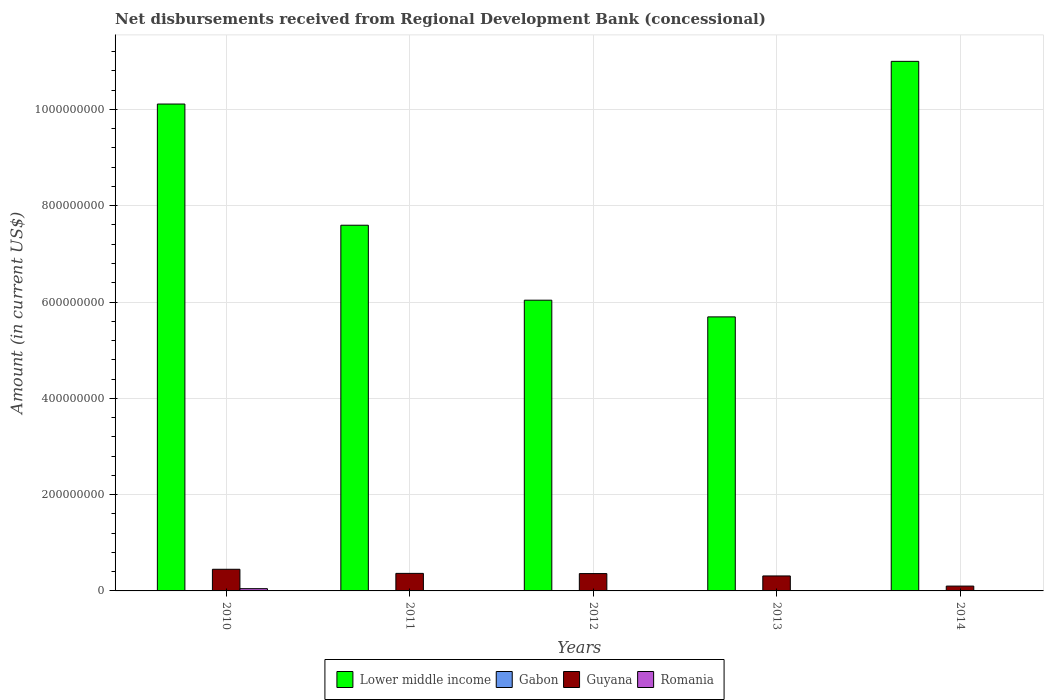What is the label of the 4th group of bars from the left?
Offer a terse response. 2013. What is the amount of disbursements received from Regional Development Bank in Gabon in 2012?
Your response must be concise. 0. Across all years, what is the maximum amount of disbursements received from Regional Development Bank in Romania?
Ensure brevity in your answer.  4.69e+06. Across all years, what is the minimum amount of disbursements received from Regional Development Bank in Lower middle income?
Offer a terse response. 5.69e+08. In which year was the amount of disbursements received from Regional Development Bank in Lower middle income maximum?
Provide a succinct answer. 2014. What is the total amount of disbursements received from Regional Development Bank in Romania in the graph?
Make the answer very short. 4.69e+06. What is the difference between the amount of disbursements received from Regional Development Bank in Guyana in 2011 and that in 2014?
Provide a succinct answer. 2.64e+07. What is the difference between the amount of disbursements received from Regional Development Bank in Gabon in 2011 and the amount of disbursements received from Regional Development Bank in Lower middle income in 2014?
Provide a short and direct response. -1.10e+09. What is the average amount of disbursements received from Regional Development Bank in Guyana per year?
Keep it short and to the point. 3.17e+07. In the year 2011, what is the difference between the amount of disbursements received from Regional Development Bank in Guyana and amount of disbursements received from Regional Development Bank in Lower middle income?
Ensure brevity in your answer.  -7.23e+08. In how many years, is the amount of disbursements received from Regional Development Bank in Romania greater than 680000000 US$?
Your response must be concise. 0. What is the ratio of the amount of disbursements received from Regional Development Bank in Guyana in 2013 to that in 2014?
Your answer should be very brief. 3.1. Is the amount of disbursements received from Regional Development Bank in Guyana in 2010 less than that in 2012?
Your answer should be compact. No. What is the difference between the highest and the second highest amount of disbursements received from Regional Development Bank in Lower middle income?
Keep it short and to the point. 8.86e+07. What is the difference between the highest and the lowest amount of disbursements received from Regional Development Bank in Lower middle income?
Your answer should be compact. 5.31e+08. In how many years, is the amount of disbursements received from Regional Development Bank in Guyana greater than the average amount of disbursements received from Regional Development Bank in Guyana taken over all years?
Make the answer very short. 3. Is it the case that in every year, the sum of the amount of disbursements received from Regional Development Bank in Lower middle income and amount of disbursements received from Regional Development Bank in Gabon is greater than the sum of amount of disbursements received from Regional Development Bank in Romania and amount of disbursements received from Regional Development Bank in Guyana?
Ensure brevity in your answer.  No. How many bars are there?
Your response must be concise. 11. Are all the bars in the graph horizontal?
Your response must be concise. No. What is the difference between two consecutive major ticks on the Y-axis?
Provide a short and direct response. 2.00e+08. Where does the legend appear in the graph?
Give a very brief answer. Bottom center. How are the legend labels stacked?
Offer a terse response. Horizontal. What is the title of the graph?
Provide a succinct answer. Net disbursements received from Regional Development Bank (concessional). Does "Korea (Republic)" appear as one of the legend labels in the graph?
Offer a very short reply. No. What is the label or title of the Y-axis?
Provide a short and direct response. Amount (in current US$). What is the Amount (in current US$) of Lower middle income in 2010?
Give a very brief answer. 1.01e+09. What is the Amount (in current US$) in Guyana in 2010?
Make the answer very short. 4.50e+07. What is the Amount (in current US$) of Romania in 2010?
Make the answer very short. 4.69e+06. What is the Amount (in current US$) in Lower middle income in 2011?
Provide a short and direct response. 7.59e+08. What is the Amount (in current US$) of Guyana in 2011?
Ensure brevity in your answer.  3.64e+07. What is the Amount (in current US$) of Romania in 2011?
Your response must be concise. 0. What is the Amount (in current US$) in Lower middle income in 2012?
Keep it short and to the point. 6.04e+08. What is the Amount (in current US$) of Guyana in 2012?
Provide a short and direct response. 3.60e+07. What is the Amount (in current US$) of Romania in 2012?
Provide a succinct answer. 0. What is the Amount (in current US$) of Lower middle income in 2013?
Your response must be concise. 5.69e+08. What is the Amount (in current US$) of Guyana in 2013?
Give a very brief answer. 3.11e+07. What is the Amount (in current US$) in Lower middle income in 2014?
Your answer should be very brief. 1.10e+09. What is the Amount (in current US$) in Gabon in 2014?
Ensure brevity in your answer.  0. What is the Amount (in current US$) in Guyana in 2014?
Keep it short and to the point. 1.00e+07. Across all years, what is the maximum Amount (in current US$) in Lower middle income?
Provide a short and direct response. 1.10e+09. Across all years, what is the maximum Amount (in current US$) of Guyana?
Offer a terse response. 4.50e+07. Across all years, what is the maximum Amount (in current US$) of Romania?
Ensure brevity in your answer.  4.69e+06. Across all years, what is the minimum Amount (in current US$) of Lower middle income?
Offer a terse response. 5.69e+08. Across all years, what is the minimum Amount (in current US$) in Guyana?
Ensure brevity in your answer.  1.00e+07. Across all years, what is the minimum Amount (in current US$) of Romania?
Provide a short and direct response. 0. What is the total Amount (in current US$) in Lower middle income in the graph?
Your response must be concise. 4.04e+09. What is the total Amount (in current US$) in Guyana in the graph?
Your answer should be compact. 1.59e+08. What is the total Amount (in current US$) in Romania in the graph?
Offer a terse response. 4.69e+06. What is the difference between the Amount (in current US$) in Lower middle income in 2010 and that in 2011?
Provide a succinct answer. 2.52e+08. What is the difference between the Amount (in current US$) of Guyana in 2010 and that in 2011?
Provide a short and direct response. 8.54e+06. What is the difference between the Amount (in current US$) in Lower middle income in 2010 and that in 2012?
Give a very brief answer. 4.07e+08. What is the difference between the Amount (in current US$) in Guyana in 2010 and that in 2012?
Offer a terse response. 8.96e+06. What is the difference between the Amount (in current US$) in Lower middle income in 2010 and that in 2013?
Provide a succinct answer. 4.42e+08. What is the difference between the Amount (in current US$) of Guyana in 2010 and that in 2013?
Provide a short and direct response. 1.39e+07. What is the difference between the Amount (in current US$) of Lower middle income in 2010 and that in 2014?
Ensure brevity in your answer.  -8.86e+07. What is the difference between the Amount (in current US$) of Guyana in 2010 and that in 2014?
Provide a succinct answer. 3.49e+07. What is the difference between the Amount (in current US$) of Lower middle income in 2011 and that in 2012?
Your answer should be very brief. 1.56e+08. What is the difference between the Amount (in current US$) of Guyana in 2011 and that in 2012?
Your answer should be very brief. 4.26e+05. What is the difference between the Amount (in current US$) in Lower middle income in 2011 and that in 2013?
Offer a terse response. 1.90e+08. What is the difference between the Amount (in current US$) of Guyana in 2011 and that in 2013?
Provide a short and direct response. 5.32e+06. What is the difference between the Amount (in current US$) of Lower middle income in 2011 and that in 2014?
Your answer should be very brief. -3.40e+08. What is the difference between the Amount (in current US$) of Guyana in 2011 and that in 2014?
Provide a succinct answer. 2.64e+07. What is the difference between the Amount (in current US$) of Lower middle income in 2012 and that in 2013?
Give a very brief answer. 3.47e+07. What is the difference between the Amount (in current US$) of Guyana in 2012 and that in 2013?
Offer a very short reply. 4.90e+06. What is the difference between the Amount (in current US$) of Lower middle income in 2012 and that in 2014?
Your response must be concise. -4.96e+08. What is the difference between the Amount (in current US$) in Guyana in 2012 and that in 2014?
Keep it short and to the point. 2.60e+07. What is the difference between the Amount (in current US$) of Lower middle income in 2013 and that in 2014?
Offer a very short reply. -5.31e+08. What is the difference between the Amount (in current US$) of Guyana in 2013 and that in 2014?
Your answer should be very brief. 2.11e+07. What is the difference between the Amount (in current US$) of Lower middle income in 2010 and the Amount (in current US$) of Guyana in 2011?
Ensure brevity in your answer.  9.75e+08. What is the difference between the Amount (in current US$) of Lower middle income in 2010 and the Amount (in current US$) of Guyana in 2012?
Make the answer very short. 9.75e+08. What is the difference between the Amount (in current US$) in Lower middle income in 2010 and the Amount (in current US$) in Guyana in 2013?
Ensure brevity in your answer.  9.80e+08. What is the difference between the Amount (in current US$) of Lower middle income in 2010 and the Amount (in current US$) of Guyana in 2014?
Provide a short and direct response. 1.00e+09. What is the difference between the Amount (in current US$) of Lower middle income in 2011 and the Amount (in current US$) of Guyana in 2012?
Offer a terse response. 7.23e+08. What is the difference between the Amount (in current US$) in Lower middle income in 2011 and the Amount (in current US$) in Guyana in 2013?
Keep it short and to the point. 7.28e+08. What is the difference between the Amount (in current US$) of Lower middle income in 2011 and the Amount (in current US$) of Guyana in 2014?
Your answer should be compact. 7.49e+08. What is the difference between the Amount (in current US$) in Lower middle income in 2012 and the Amount (in current US$) in Guyana in 2013?
Your answer should be very brief. 5.73e+08. What is the difference between the Amount (in current US$) of Lower middle income in 2012 and the Amount (in current US$) of Guyana in 2014?
Your answer should be very brief. 5.94e+08. What is the difference between the Amount (in current US$) of Lower middle income in 2013 and the Amount (in current US$) of Guyana in 2014?
Make the answer very short. 5.59e+08. What is the average Amount (in current US$) in Lower middle income per year?
Provide a short and direct response. 8.09e+08. What is the average Amount (in current US$) of Gabon per year?
Give a very brief answer. 0. What is the average Amount (in current US$) in Guyana per year?
Provide a short and direct response. 3.17e+07. What is the average Amount (in current US$) of Romania per year?
Give a very brief answer. 9.38e+05. In the year 2010, what is the difference between the Amount (in current US$) of Lower middle income and Amount (in current US$) of Guyana?
Make the answer very short. 9.66e+08. In the year 2010, what is the difference between the Amount (in current US$) in Lower middle income and Amount (in current US$) in Romania?
Ensure brevity in your answer.  1.01e+09. In the year 2010, what is the difference between the Amount (in current US$) in Guyana and Amount (in current US$) in Romania?
Offer a terse response. 4.03e+07. In the year 2011, what is the difference between the Amount (in current US$) in Lower middle income and Amount (in current US$) in Guyana?
Your answer should be compact. 7.23e+08. In the year 2012, what is the difference between the Amount (in current US$) in Lower middle income and Amount (in current US$) in Guyana?
Your answer should be very brief. 5.68e+08. In the year 2013, what is the difference between the Amount (in current US$) in Lower middle income and Amount (in current US$) in Guyana?
Offer a very short reply. 5.38e+08. In the year 2014, what is the difference between the Amount (in current US$) in Lower middle income and Amount (in current US$) in Guyana?
Offer a terse response. 1.09e+09. What is the ratio of the Amount (in current US$) in Lower middle income in 2010 to that in 2011?
Give a very brief answer. 1.33. What is the ratio of the Amount (in current US$) in Guyana in 2010 to that in 2011?
Offer a very short reply. 1.23. What is the ratio of the Amount (in current US$) of Lower middle income in 2010 to that in 2012?
Give a very brief answer. 1.67. What is the ratio of the Amount (in current US$) in Guyana in 2010 to that in 2012?
Offer a terse response. 1.25. What is the ratio of the Amount (in current US$) in Lower middle income in 2010 to that in 2013?
Give a very brief answer. 1.78. What is the ratio of the Amount (in current US$) of Guyana in 2010 to that in 2013?
Provide a short and direct response. 1.45. What is the ratio of the Amount (in current US$) of Lower middle income in 2010 to that in 2014?
Your response must be concise. 0.92. What is the ratio of the Amount (in current US$) in Guyana in 2010 to that in 2014?
Make the answer very short. 4.48. What is the ratio of the Amount (in current US$) in Lower middle income in 2011 to that in 2012?
Your answer should be very brief. 1.26. What is the ratio of the Amount (in current US$) of Guyana in 2011 to that in 2012?
Your answer should be very brief. 1.01. What is the ratio of the Amount (in current US$) of Lower middle income in 2011 to that in 2013?
Make the answer very short. 1.33. What is the ratio of the Amount (in current US$) in Guyana in 2011 to that in 2013?
Ensure brevity in your answer.  1.17. What is the ratio of the Amount (in current US$) in Lower middle income in 2011 to that in 2014?
Your answer should be compact. 0.69. What is the ratio of the Amount (in current US$) in Guyana in 2011 to that in 2014?
Offer a very short reply. 3.63. What is the ratio of the Amount (in current US$) of Lower middle income in 2012 to that in 2013?
Your answer should be compact. 1.06. What is the ratio of the Amount (in current US$) of Guyana in 2012 to that in 2013?
Provide a short and direct response. 1.16. What is the ratio of the Amount (in current US$) in Lower middle income in 2012 to that in 2014?
Ensure brevity in your answer.  0.55. What is the ratio of the Amount (in current US$) in Guyana in 2012 to that in 2014?
Ensure brevity in your answer.  3.59. What is the ratio of the Amount (in current US$) of Lower middle income in 2013 to that in 2014?
Offer a very short reply. 0.52. What is the ratio of the Amount (in current US$) of Guyana in 2013 to that in 2014?
Make the answer very short. 3.1. What is the difference between the highest and the second highest Amount (in current US$) in Lower middle income?
Provide a short and direct response. 8.86e+07. What is the difference between the highest and the second highest Amount (in current US$) in Guyana?
Offer a terse response. 8.54e+06. What is the difference between the highest and the lowest Amount (in current US$) in Lower middle income?
Offer a terse response. 5.31e+08. What is the difference between the highest and the lowest Amount (in current US$) in Guyana?
Provide a short and direct response. 3.49e+07. What is the difference between the highest and the lowest Amount (in current US$) of Romania?
Your response must be concise. 4.69e+06. 